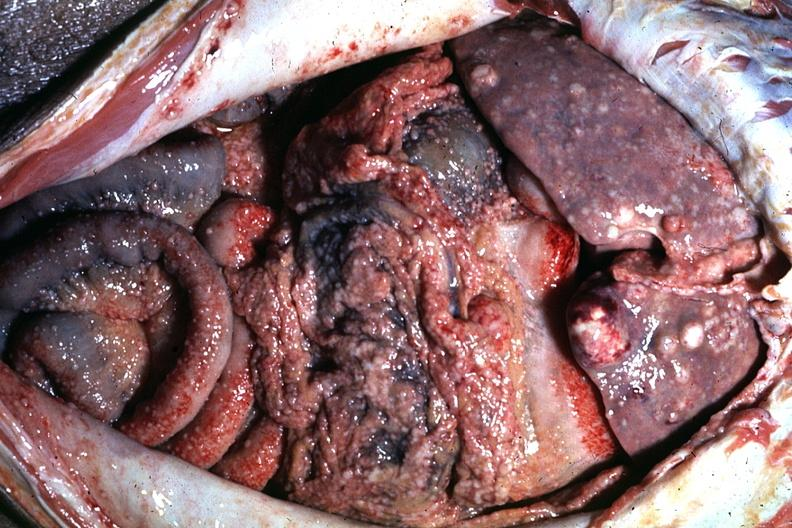s this section showing liver with tumor mass in hilar area tumor present?
Answer the question using a single word or phrase. No 